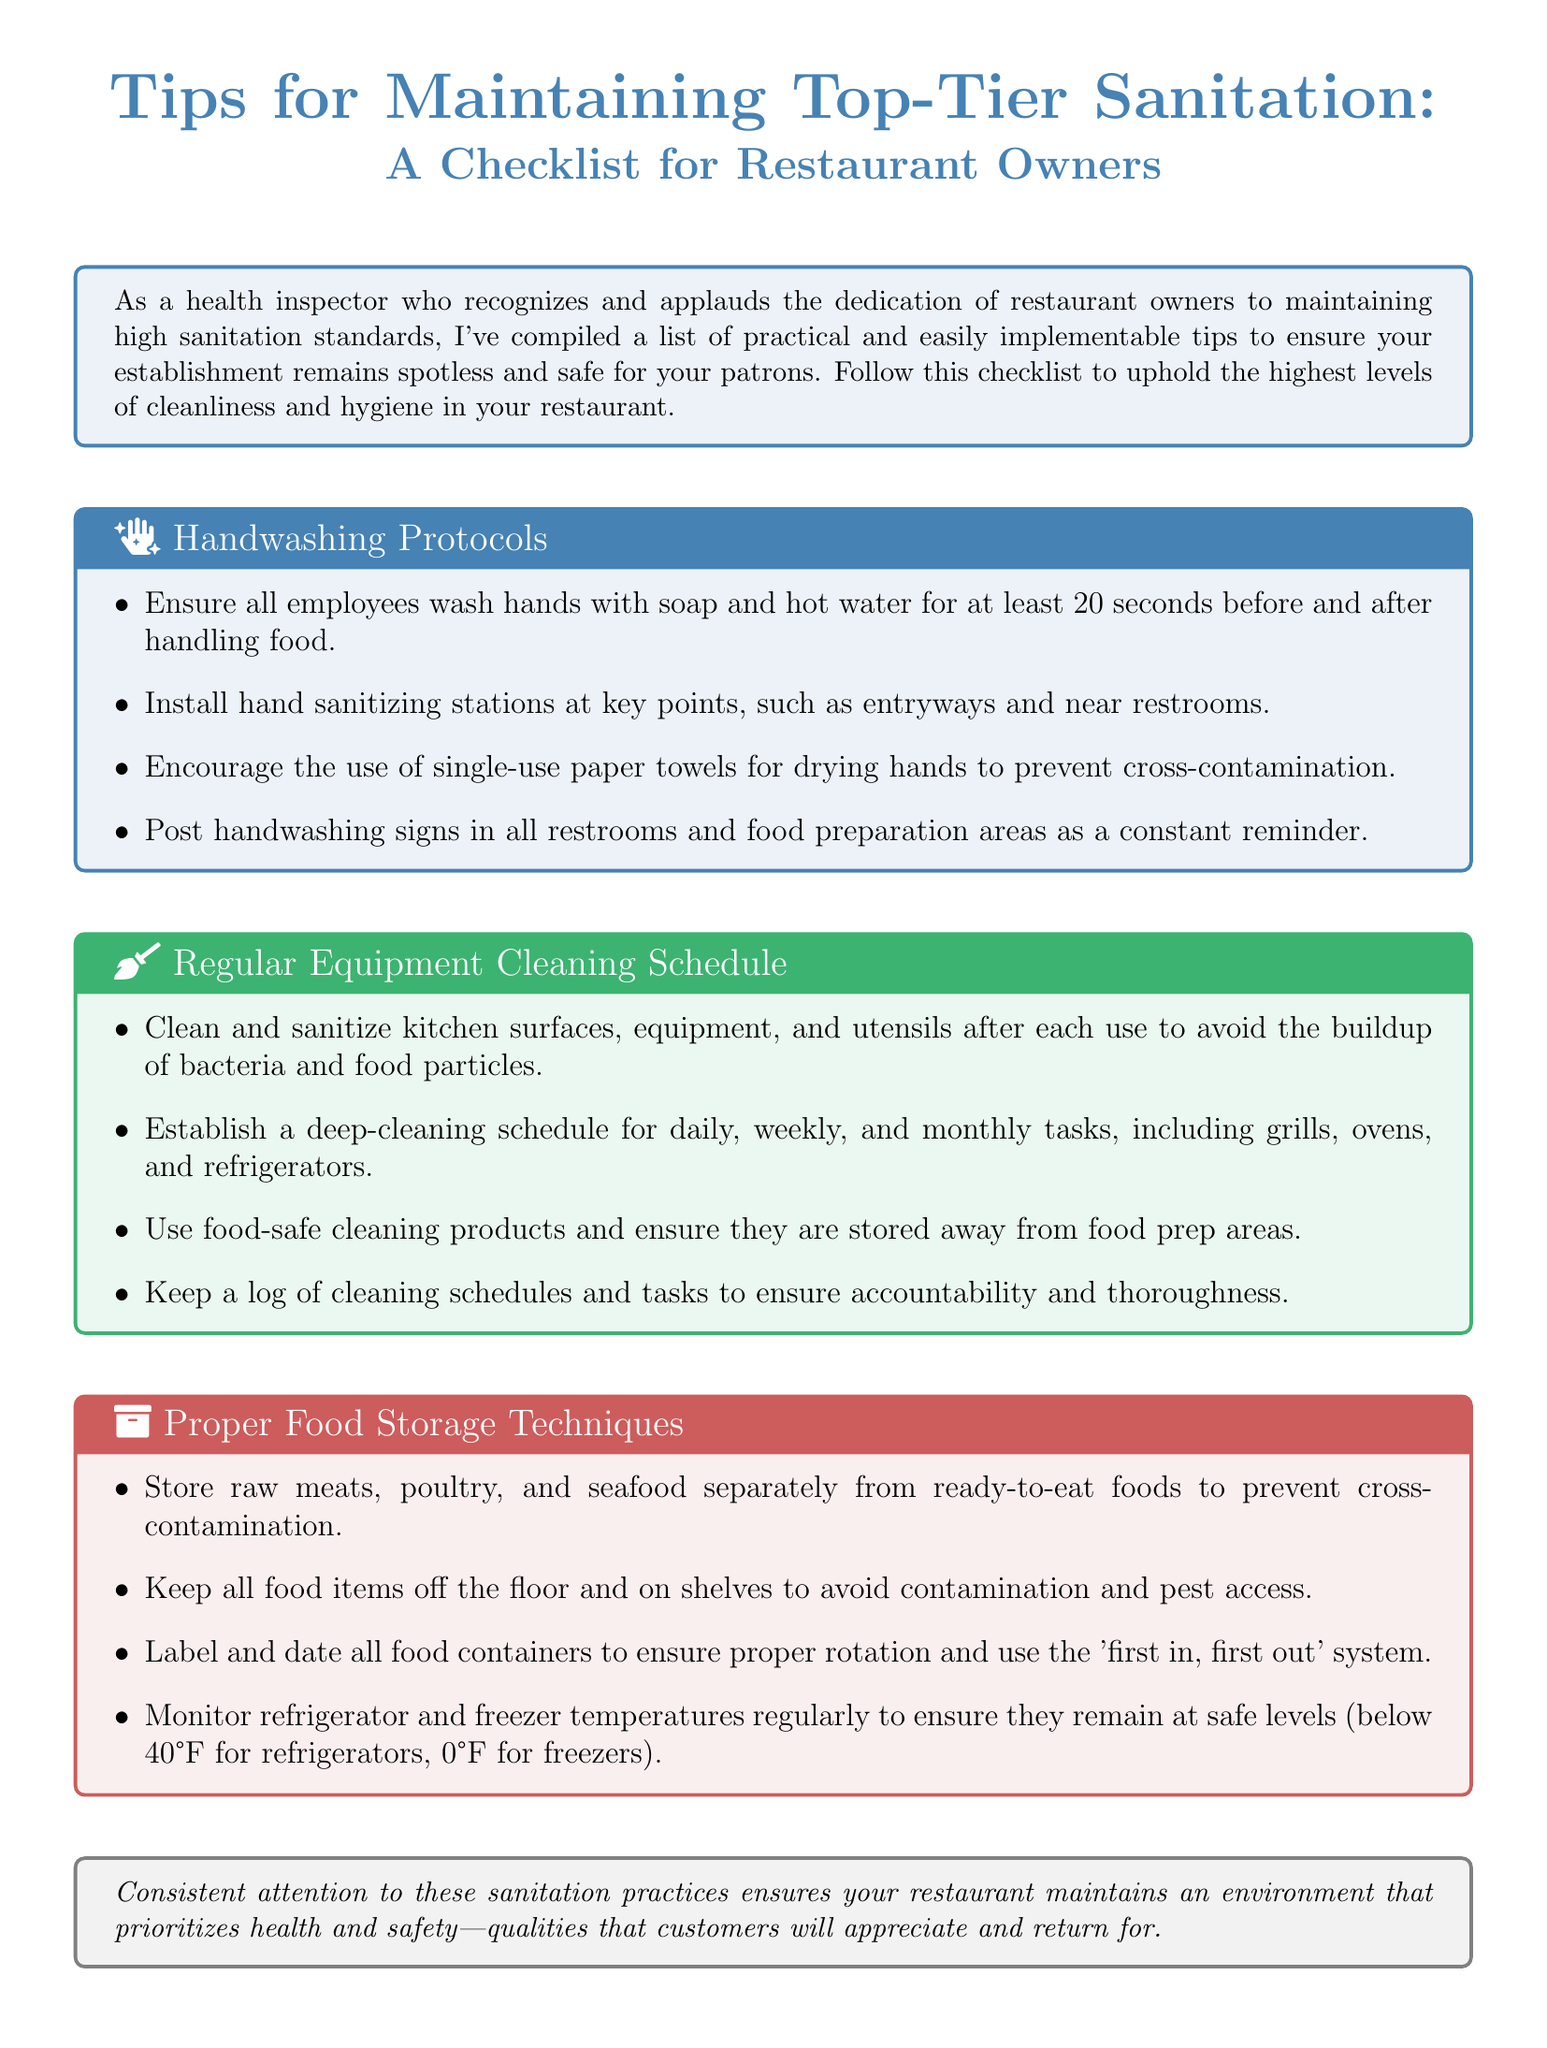What are the handwashing protocols? The handwashing protocols are listed in the first section of the document and include washing hands for at least 20 seconds, installing hand sanitizing stations, using single-use paper towels, and posting signs.
Answer: 20 seconds What color is the section on Regular Equipment Cleaning Schedule? The section on Regular Equipment Cleaning Schedule is indicated with a color code in the document.
Answer: Greenish What should food containers be labeled with? The document specifies that food containers should be labeled with dates for proper food storage techniques.
Answer: Dates What is the purpose of the document? The purpose of the document is to provide a checklist of sanitation tips for restaurant owners to maintain hygiene in their establishments.
Answer: To provide a checklist How often should kitchens be cleaned according to the document? The frequency of kitchen cleaning tasks varies and is specified as daily, weekly, and monthly in the Regular Equipment Cleaning Schedule section.
Answer: Daily, weekly, monthly What icon represents proper food storage techniques? The section on Proper Food Storage Techniques includes an icon to enhance engagement and readability.
Answer: Archive icon 